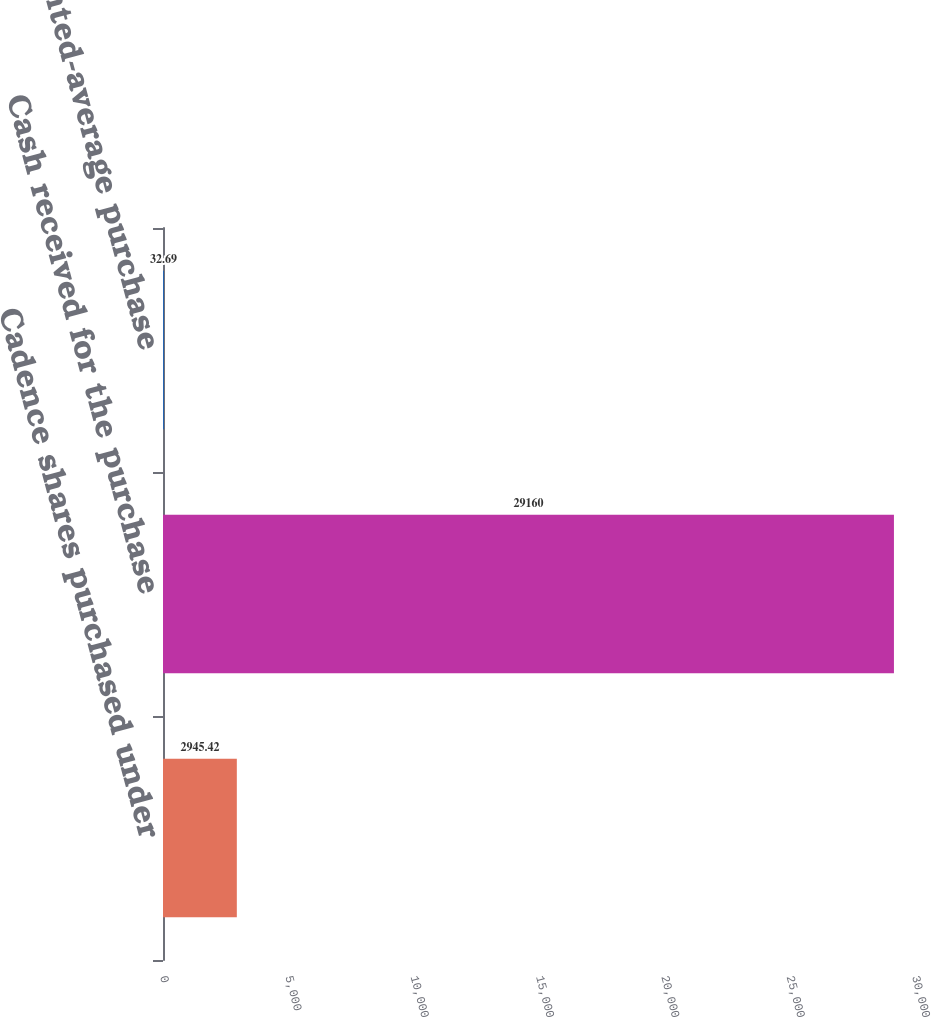<chart> <loc_0><loc_0><loc_500><loc_500><bar_chart><fcel>Cadence shares purchased under<fcel>Cash received for the purchase<fcel>Weighted-average purchase<nl><fcel>2945.42<fcel>29160<fcel>32.69<nl></chart> 